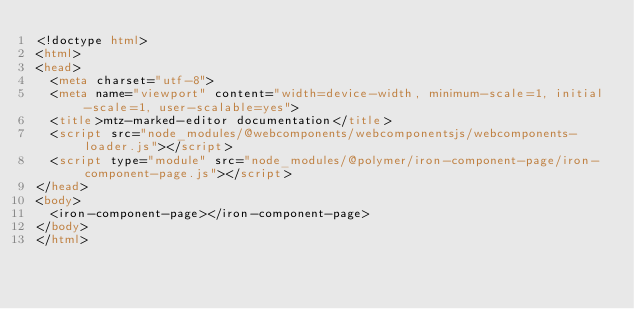Convert code to text. <code><loc_0><loc_0><loc_500><loc_500><_HTML_><!doctype html>
<html>
<head>
  <meta charset="utf-8">
  <meta name="viewport" content="width=device-width, minimum-scale=1, initial-scale=1, user-scalable=yes">
  <title>mtz-marked-editor documentation</title>
  <script src="node_modules/@webcomponents/webcomponentsjs/webcomponents-loader.js"></script>
  <script type="module" src="node_modules/@polymer/iron-component-page/iron-component-page.js"></script>
</head>
<body>
  <iron-component-page></iron-component-page>
</body>
</html>
</code> 